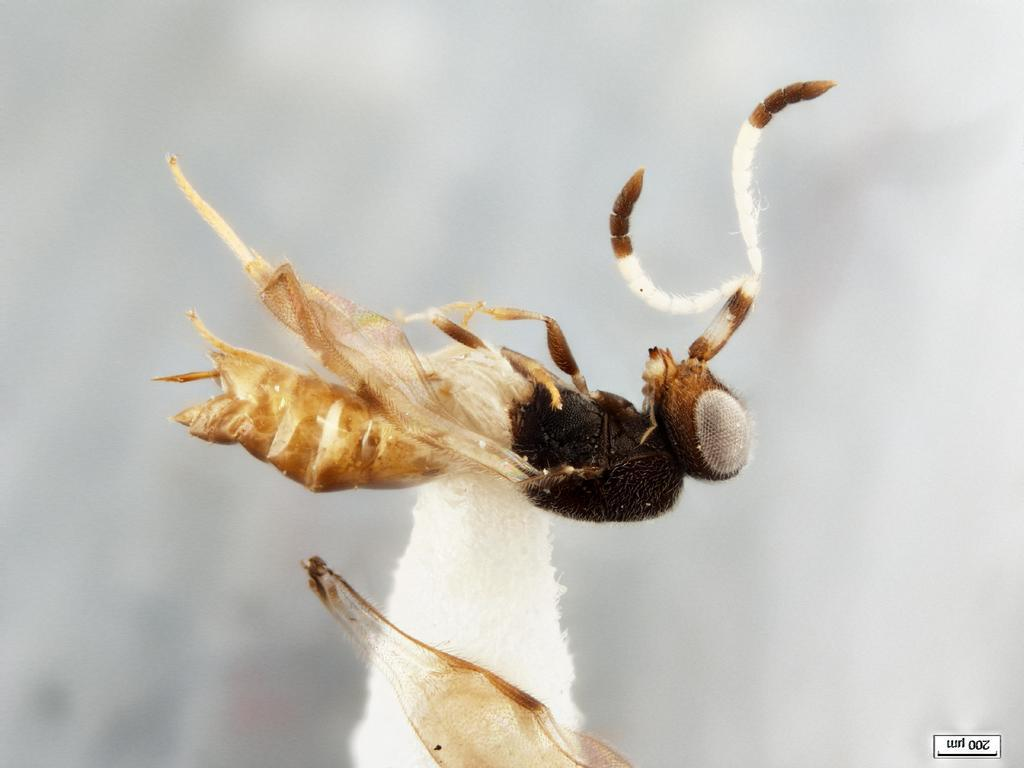What is present in the image besides the background? There is an insect in the picture. Can you describe any additional features of the image? There is a watermark at the bottom right corner of the image. What color is the background of the image? The background of the image is white. Where is the stage located in the image? There is no stage present in the image. What type of square can be seen in the image? There is no square present in the image. 